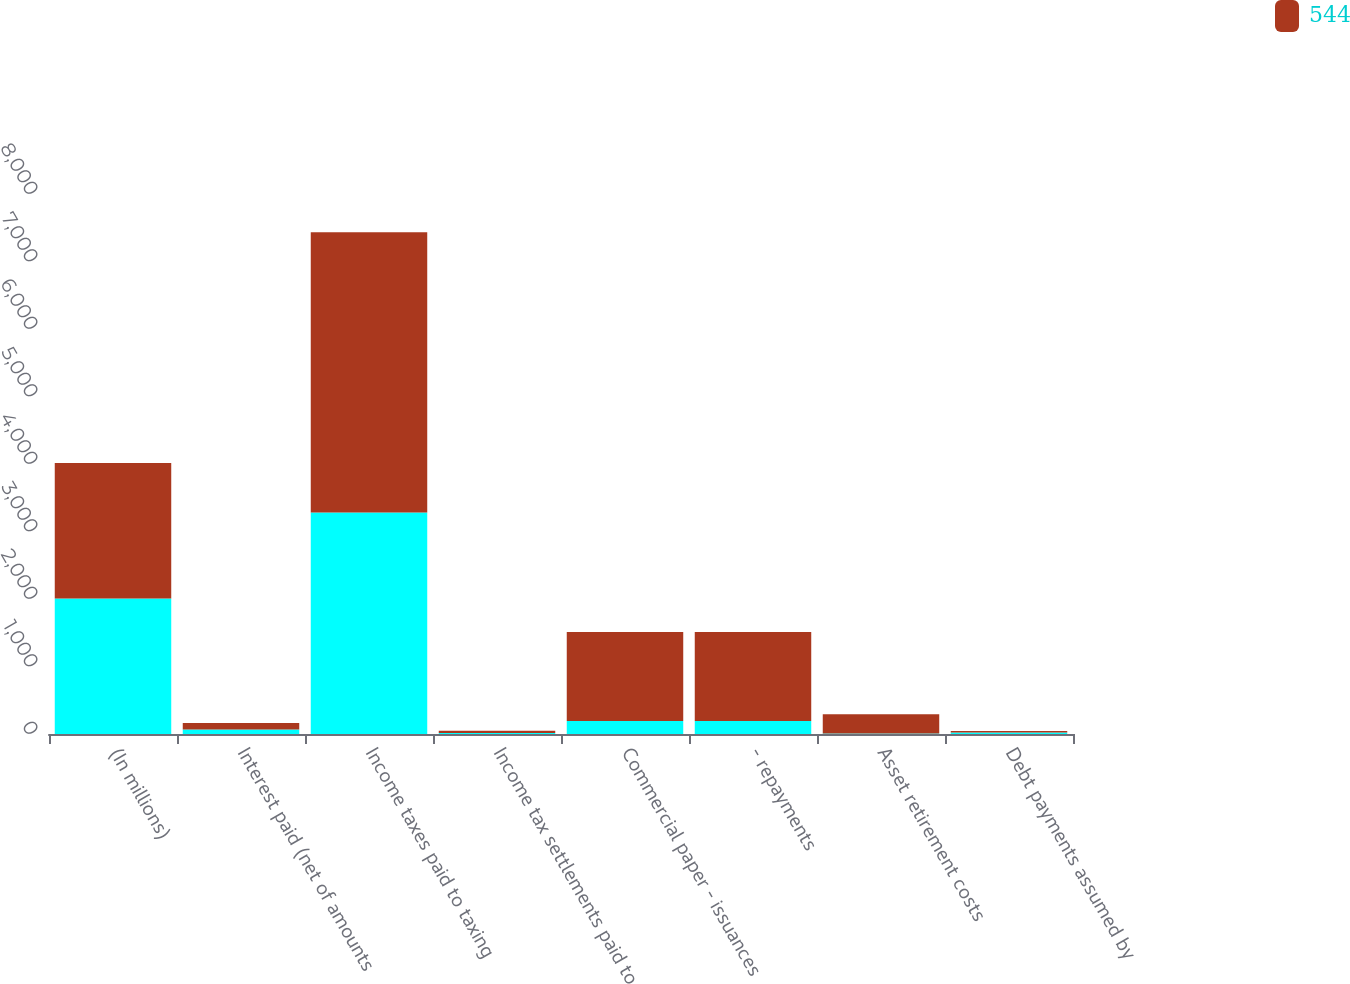Convert chart. <chart><loc_0><loc_0><loc_500><loc_500><stacked_bar_chart><ecel><fcel>(In millions)<fcel>Interest paid (net of amounts<fcel>Income taxes paid to taxing<fcel>Income tax settlements paid to<fcel>Commercial paper - issuances<fcel>- repayments<fcel>Asset retirement costs<fcel>Debt payments assumed by<nl><fcel>nan<fcel>2007<fcel>66<fcel>3283<fcel>13<fcel>191<fcel>191<fcel>8<fcel>21<nl><fcel>544<fcel>2006<fcel>96<fcel>4149<fcel>35<fcel>1321<fcel>1321<fcel>286<fcel>24<nl></chart> 